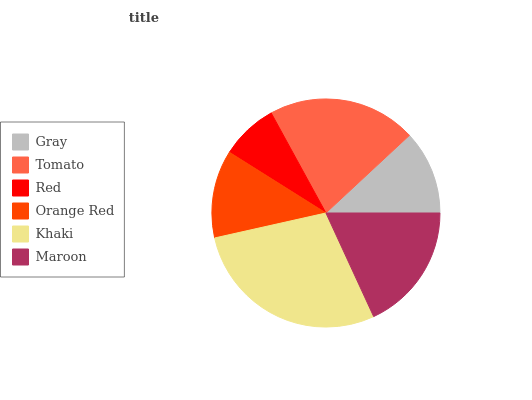Is Red the minimum?
Answer yes or no. Yes. Is Khaki the maximum?
Answer yes or no. Yes. Is Tomato the minimum?
Answer yes or no. No. Is Tomato the maximum?
Answer yes or no. No. Is Tomato greater than Gray?
Answer yes or no. Yes. Is Gray less than Tomato?
Answer yes or no. Yes. Is Gray greater than Tomato?
Answer yes or no. No. Is Tomato less than Gray?
Answer yes or no. No. Is Maroon the high median?
Answer yes or no. Yes. Is Orange Red the low median?
Answer yes or no. Yes. Is Red the high median?
Answer yes or no. No. Is Khaki the low median?
Answer yes or no. No. 